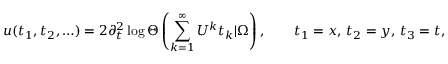<formula> <loc_0><loc_0><loc_500><loc_500>u ( t _ { 1 } , t _ { 2 } , \dots ) = 2 \partial _ { t } ^ { 2 } \log \Theta \left ( \sum _ { k = 1 } ^ { \infty } U ^ { k } t _ { k } | \Omega \right ) , \quad t _ { 1 } = x , \, t _ { 2 } = y , \, t _ { 3 } = t ,</formula> 